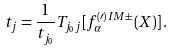<formula> <loc_0><loc_0><loc_500><loc_500>t _ { j } = \frac { 1 } { t _ { j _ { 0 } } } T _ { j _ { 0 } j } [ f ^ { ( \prime ) I M \pm } _ { \alpha } ( X ) ] \, .</formula> 